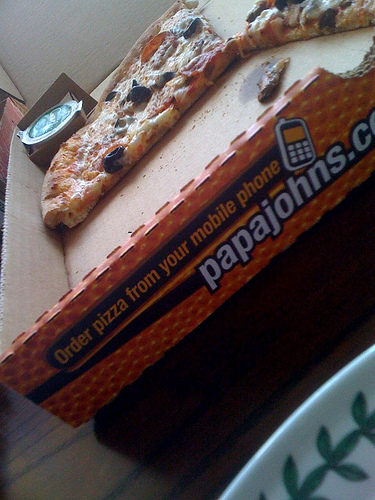Please identify all text content in this image. order pizza from your mobile papajohns.c Phone 